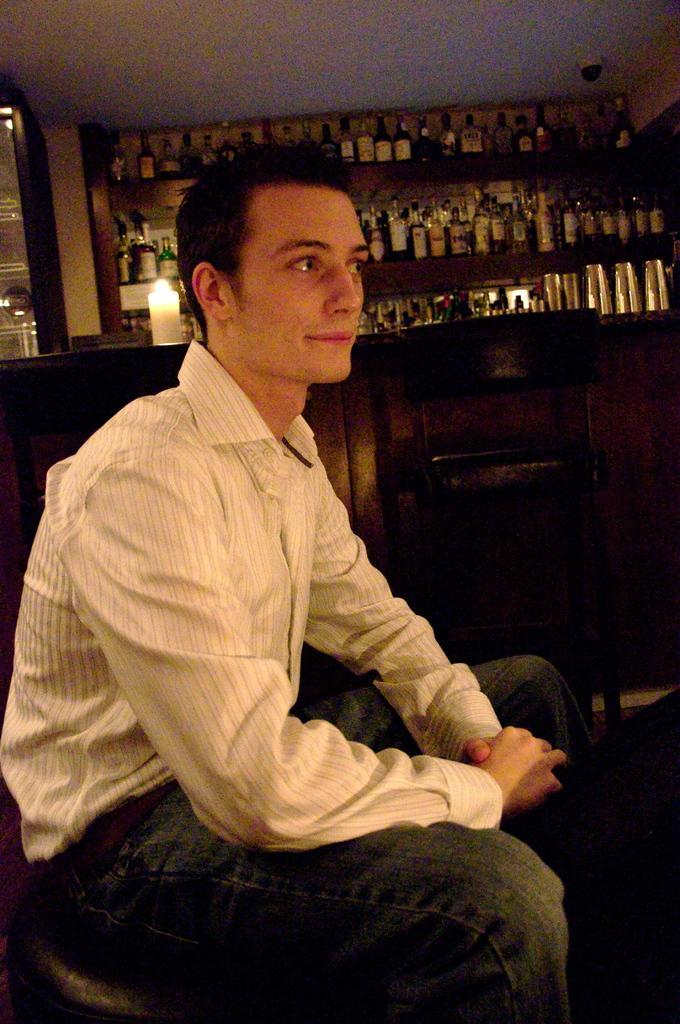How would you summarize this image in a sentence or two? In this image in the front there is a man sitting. In the center there is an empty chair. In the background there are bottles, there is a candle. 